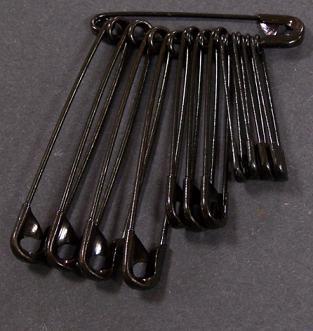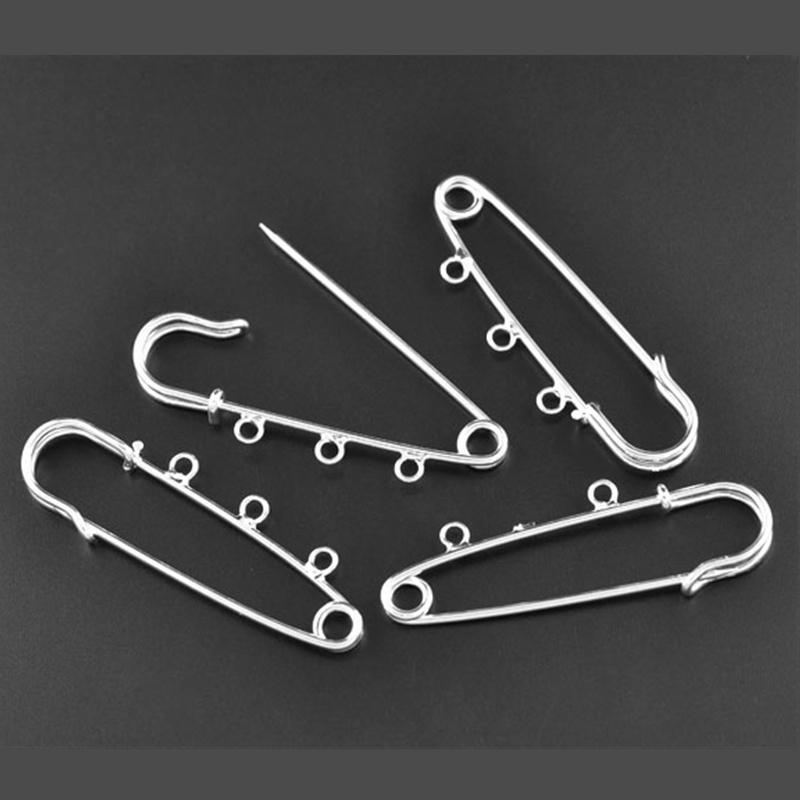The first image is the image on the left, the second image is the image on the right. For the images displayed, is the sentence "There are at least four pins in the image on the right." factually correct? Answer yes or no. Yes. 